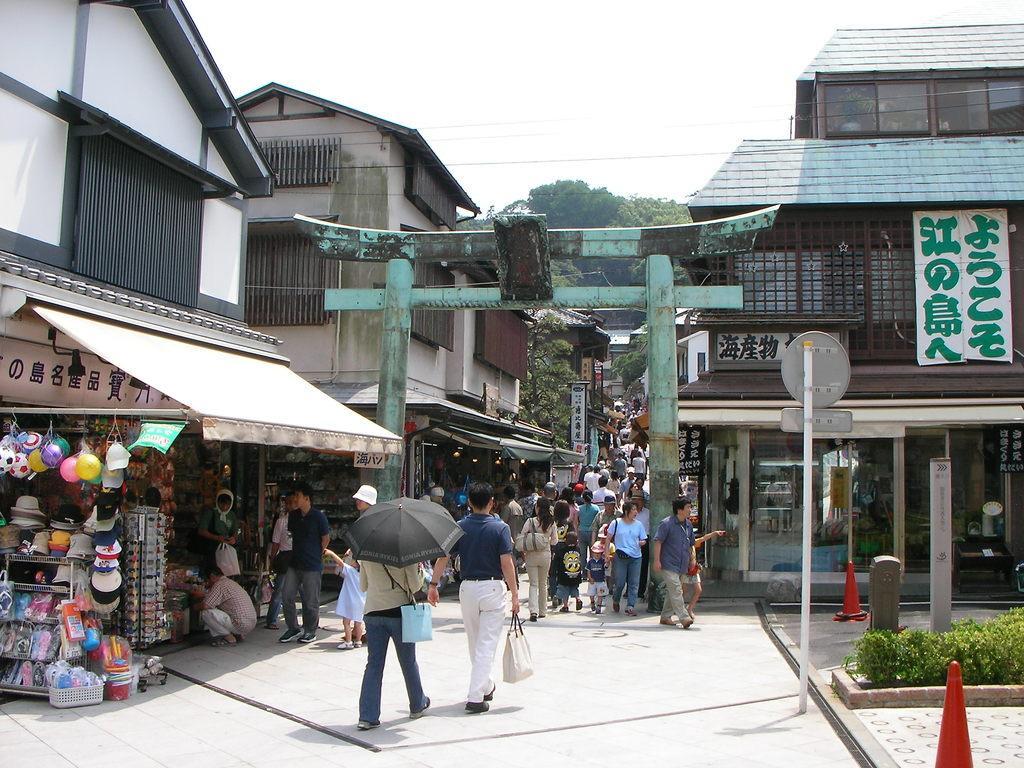Please provide a concise description of this image. In this image I can see the road, number of persons are standing on the road and I can see a person is holding a black colored umbrella. I can see few traffic poles, a pole with few boards attached to it, a green colored arch, few buildings, few toys, white colored banners to the buildings and few trees. In the background I can see the sky. 